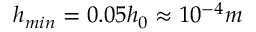<formula> <loc_0><loc_0><loc_500><loc_500>h _ { \min } = 0 . 0 5 h _ { 0 } \approx 1 0 ^ { - 4 } m</formula> 